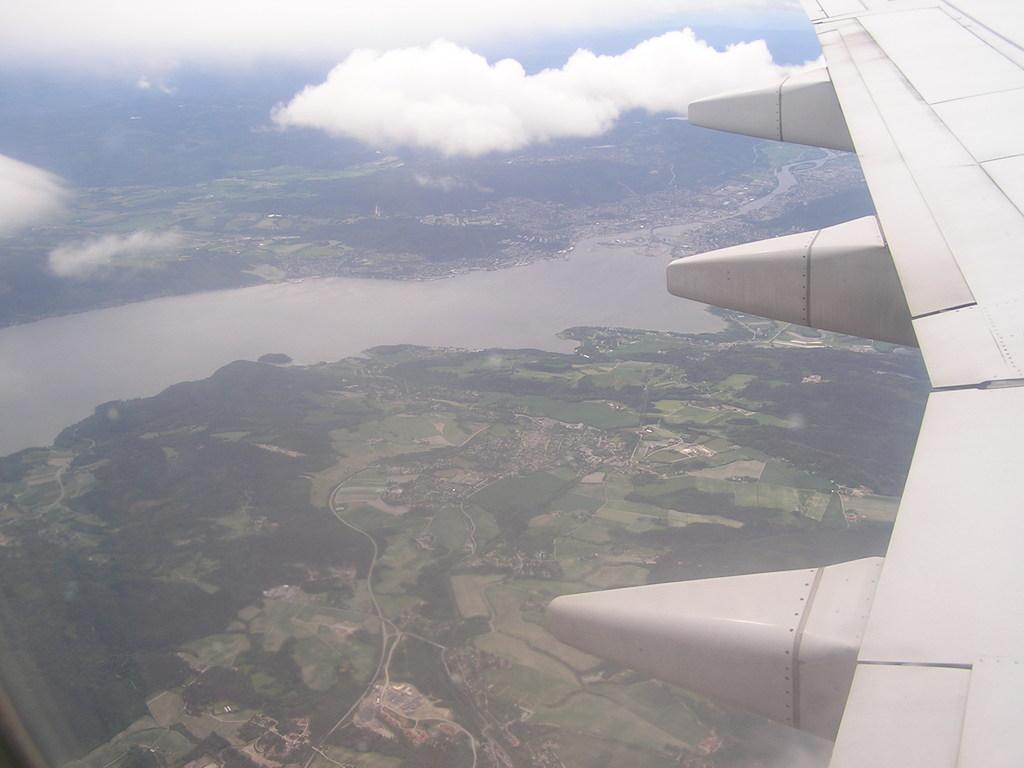What type of view is depicted in the image? The image is an aerial view. What part of an aeroplane can be seen in the image? There is an aeroplane wing visible in the image. What natural elements can be seen in the image? There are clouds, water, and trees visible in the image. What type of road can be seen in the image? There is no road visible in the image; it is an aerial view of clouds, water, trees, and an aeroplane wing. 